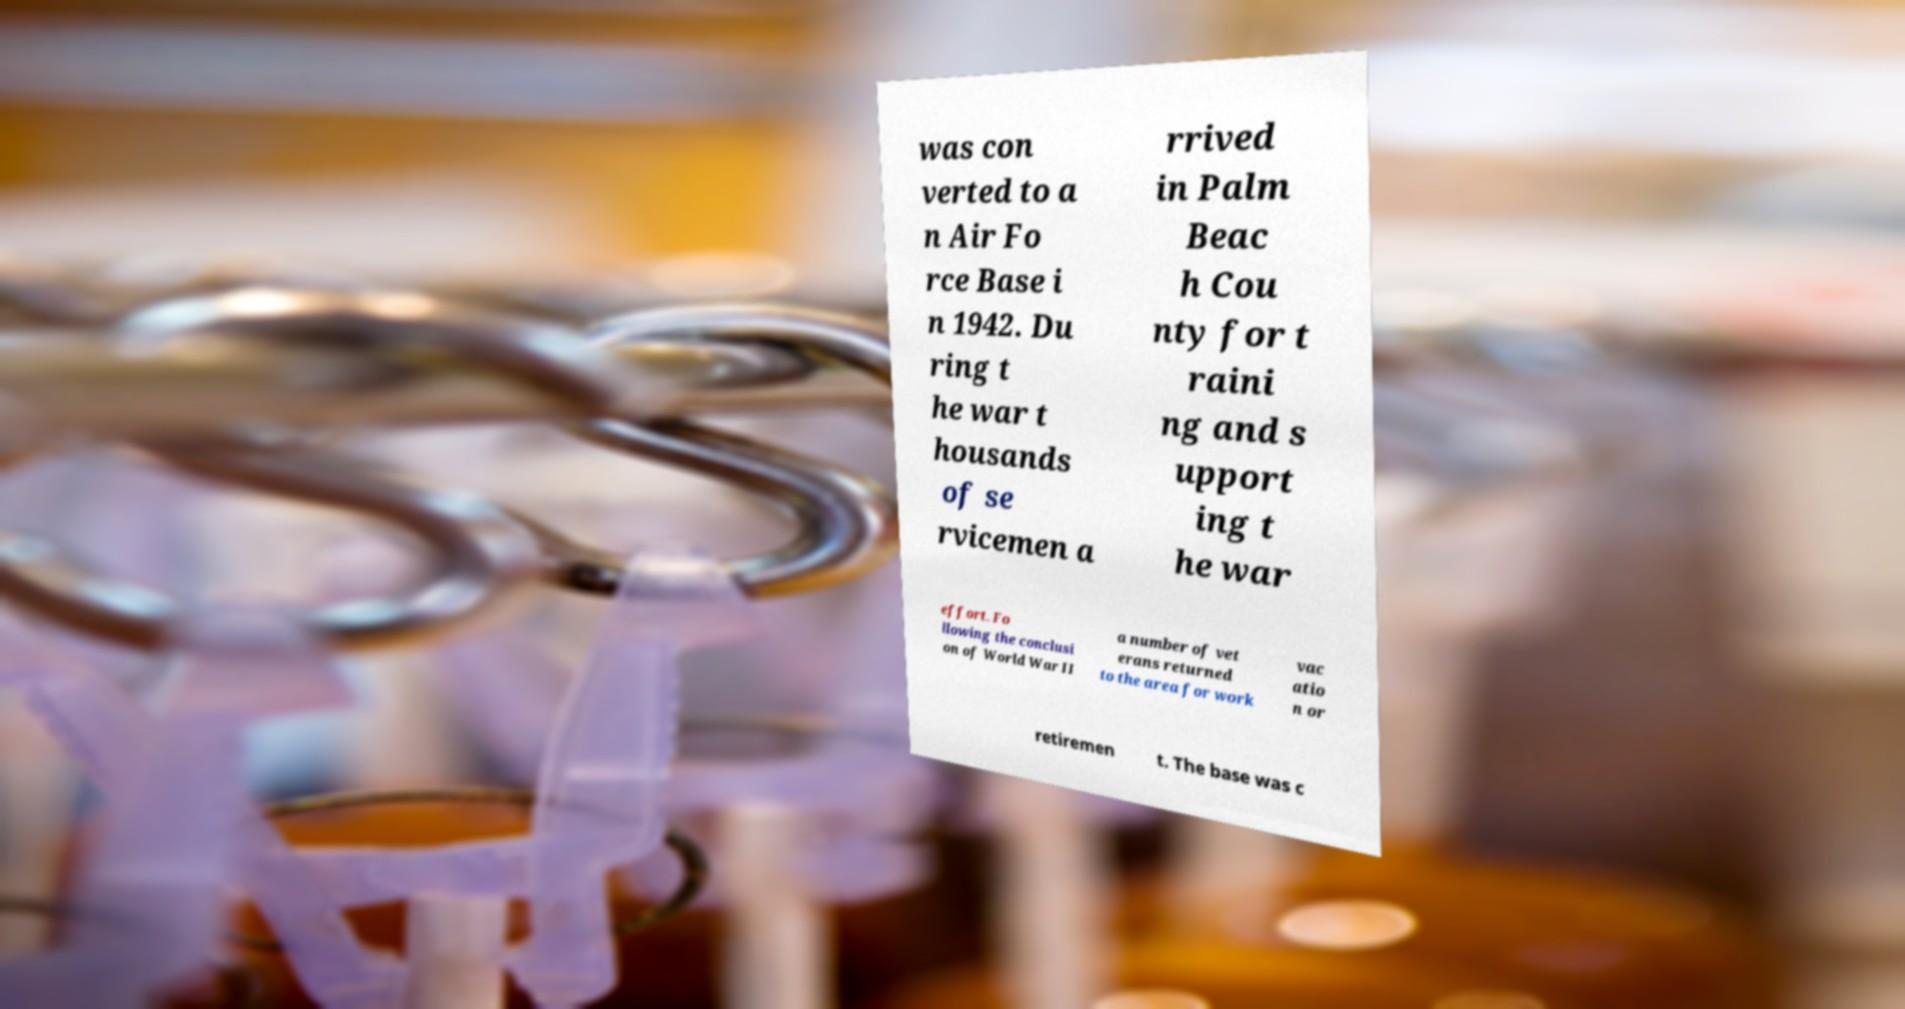What messages or text are displayed in this image? I need them in a readable, typed format. was con verted to a n Air Fo rce Base i n 1942. Du ring t he war t housands of se rvicemen a rrived in Palm Beac h Cou nty for t raini ng and s upport ing t he war effort. Fo llowing the conclusi on of World War II a number of vet erans returned to the area for work vac atio n or retiremen t. The base was c 